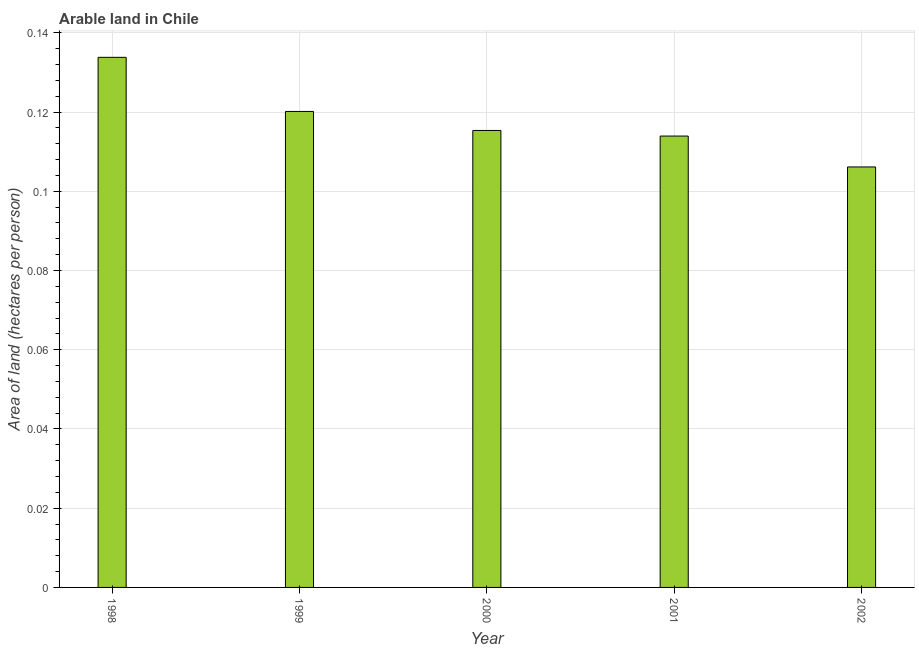What is the title of the graph?
Your answer should be compact. Arable land in Chile. What is the label or title of the X-axis?
Ensure brevity in your answer.  Year. What is the label or title of the Y-axis?
Ensure brevity in your answer.  Area of land (hectares per person). What is the area of arable land in 2001?
Give a very brief answer. 0.11. Across all years, what is the maximum area of arable land?
Offer a very short reply. 0.13. Across all years, what is the minimum area of arable land?
Give a very brief answer. 0.11. In which year was the area of arable land maximum?
Provide a short and direct response. 1998. What is the sum of the area of arable land?
Offer a terse response. 0.59. What is the difference between the area of arable land in 2000 and 2001?
Provide a short and direct response. 0. What is the average area of arable land per year?
Provide a short and direct response. 0.12. What is the median area of arable land?
Keep it short and to the point. 0.12. In how many years, is the area of arable land greater than 0.052 hectares per person?
Make the answer very short. 5. Do a majority of the years between 2000 and 2001 (inclusive) have area of arable land greater than 0.1 hectares per person?
Your answer should be compact. Yes. What is the ratio of the area of arable land in 1998 to that in 2002?
Provide a succinct answer. 1.26. Is the area of arable land in 1998 less than that in 2001?
Keep it short and to the point. No. Is the difference between the area of arable land in 2000 and 2002 greater than the difference between any two years?
Offer a very short reply. No. What is the difference between the highest and the second highest area of arable land?
Give a very brief answer. 0.01. Is the sum of the area of arable land in 1998 and 2002 greater than the maximum area of arable land across all years?
Make the answer very short. Yes. What is the difference between the highest and the lowest area of arable land?
Your response must be concise. 0.03. How many bars are there?
Your answer should be compact. 5. How many years are there in the graph?
Your response must be concise. 5. What is the difference between two consecutive major ticks on the Y-axis?
Ensure brevity in your answer.  0.02. What is the Area of land (hectares per person) in 1998?
Make the answer very short. 0.13. What is the Area of land (hectares per person) of 1999?
Offer a terse response. 0.12. What is the Area of land (hectares per person) of 2000?
Ensure brevity in your answer.  0.12. What is the Area of land (hectares per person) of 2001?
Give a very brief answer. 0.11. What is the Area of land (hectares per person) in 2002?
Make the answer very short. 0.11. What is the difference between the Area of land (hectares per person) in 1998 and 1999?
Keep it short and to the point. 0.01. What is the difference between the Area of land (hectares per person) in 1998 and 2000?
Provide a short and direct response. 0.02. What is the difference between the Area of land (hectares per person) in 1998 and 2001?
Keep it short and to the point. 0.02. What is the difference between the Area of land (hectares per person) in 1998 and 2002?
Offer a very short reply. 0.03. What is the difference between the Area of land (hectares per person) in 1999 and 2000?
Ensure brevity in your answer.  0. What is the difference between the Area of land (hectares per person) in 1999 and 2001?
Provide a short and direct response. 0.01. What is the difference between the Area of land (hectares per person) in 1999 and 2002?
Ensure brevity in your answer.  0.01. What is the difference between the Area of land (hectares per person) in 2000 and 2001?
Your answer should be very brief. 0. What is the difference between the Area of land (hectares per person) in 2000 and 2002?
Make the answer very short. 0.01. What is the difference between the Area of land (hectares per person) in 2001 and 2002?
Ensure brevity in your answer.  0.01. What is the ratio of the Area of land (hectares per person) in 1998 to that in 1999?
Ensure brevity in your answer.  1.11. What is the ratio of the Area of land (hectares per person) in 1998 to that in 2000?
Provide a succinct answer. 1.16. What is the ratio of the Area of land (hectares per person) in 1998 to that in 2001?
Provide a succinct answer. 1.17. What is the ratio of the Area of land (hectares per person) in 1998 to that in 2002?
Provide a short and direct response. 1.26. What is the ratio of the Area of land (hectares per person) in 1999 to that in 2000?
Your answer should be compact. 1.04. What is the ratio of the Area of land (hectares per person) in 1999 to that in 2001?
Provide a succinct answer. 1.05. What is the ratio of the Area of land (hectares per person) in 1999 to that in 2002?
Offer a terse response. 1.13. What is the ratio of the Area of land (hectares per person) in 2000 to that in 2001?
Your response must be concise. 1.01. What is the ratio of the Area of land (hectares per person) in 2000 to that in 2002?
Make the answer very short. 1.09. What is the ratio of the Area of land (hectares per person) in 2001 to that in 2002?
Make the answer very short. 1.07. 